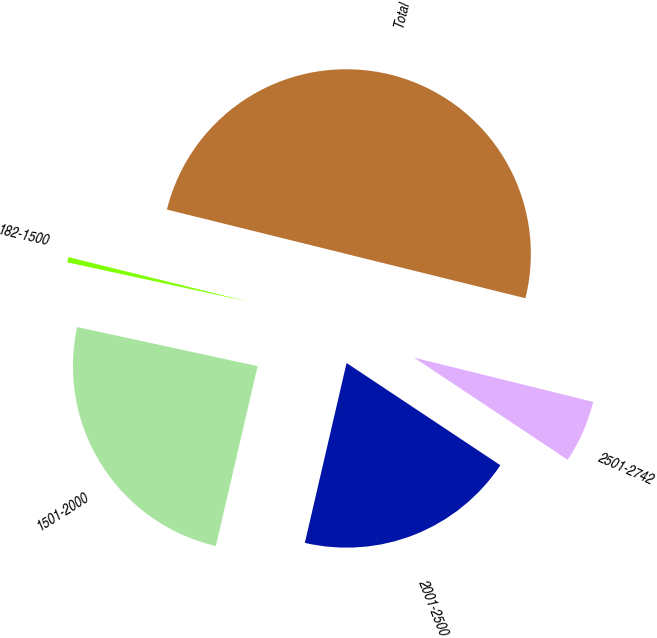<chart> <loc_0><loc_0><loc_500><loc_500><pie_chart><fcel>182-1500<fcel>1501-2000<fcel>2001-2500<fcel>2501-2742<fcel>Total<nl><fcel>0.46%<fcel>24.77%<fcel>19.29%<fcel>5.48%<fcel>50.0%<nl></chart> 